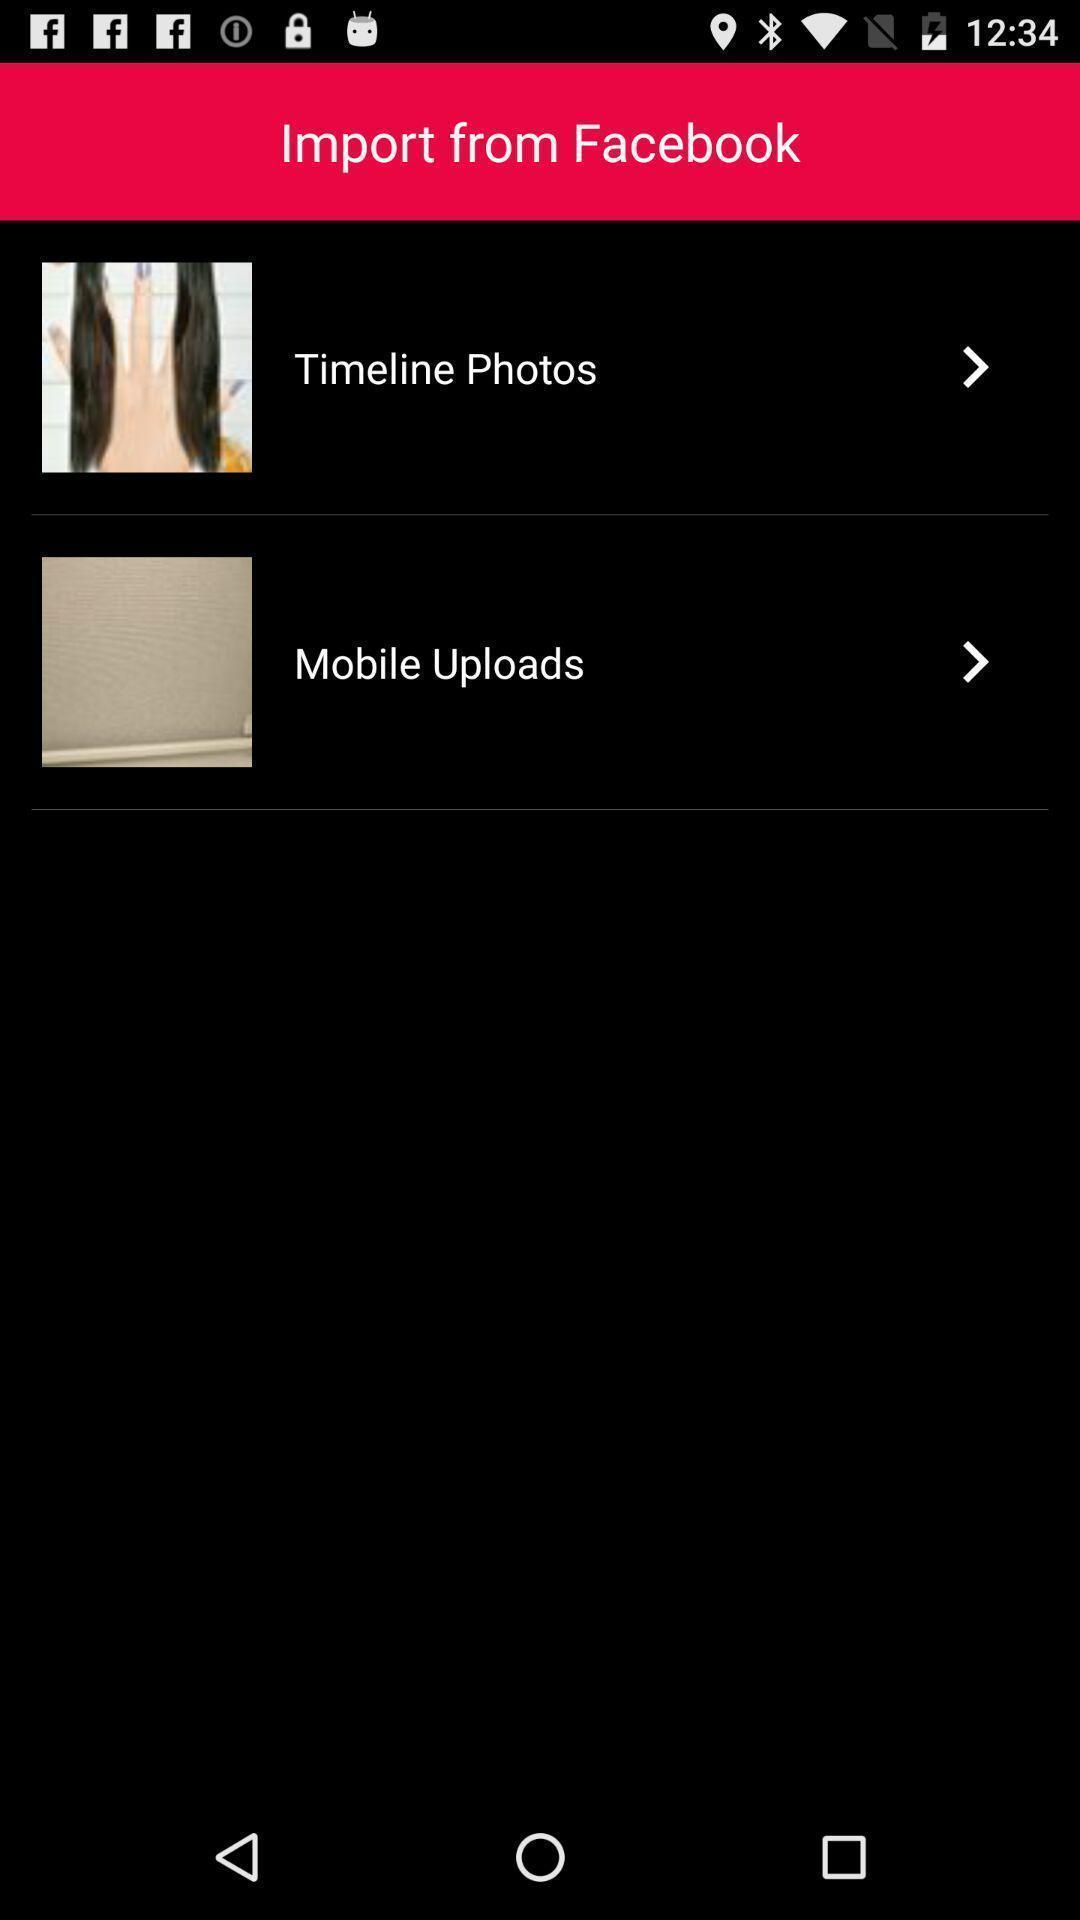Give me a summary of this screen capture. Screen displaying the folders to import from facebook. 